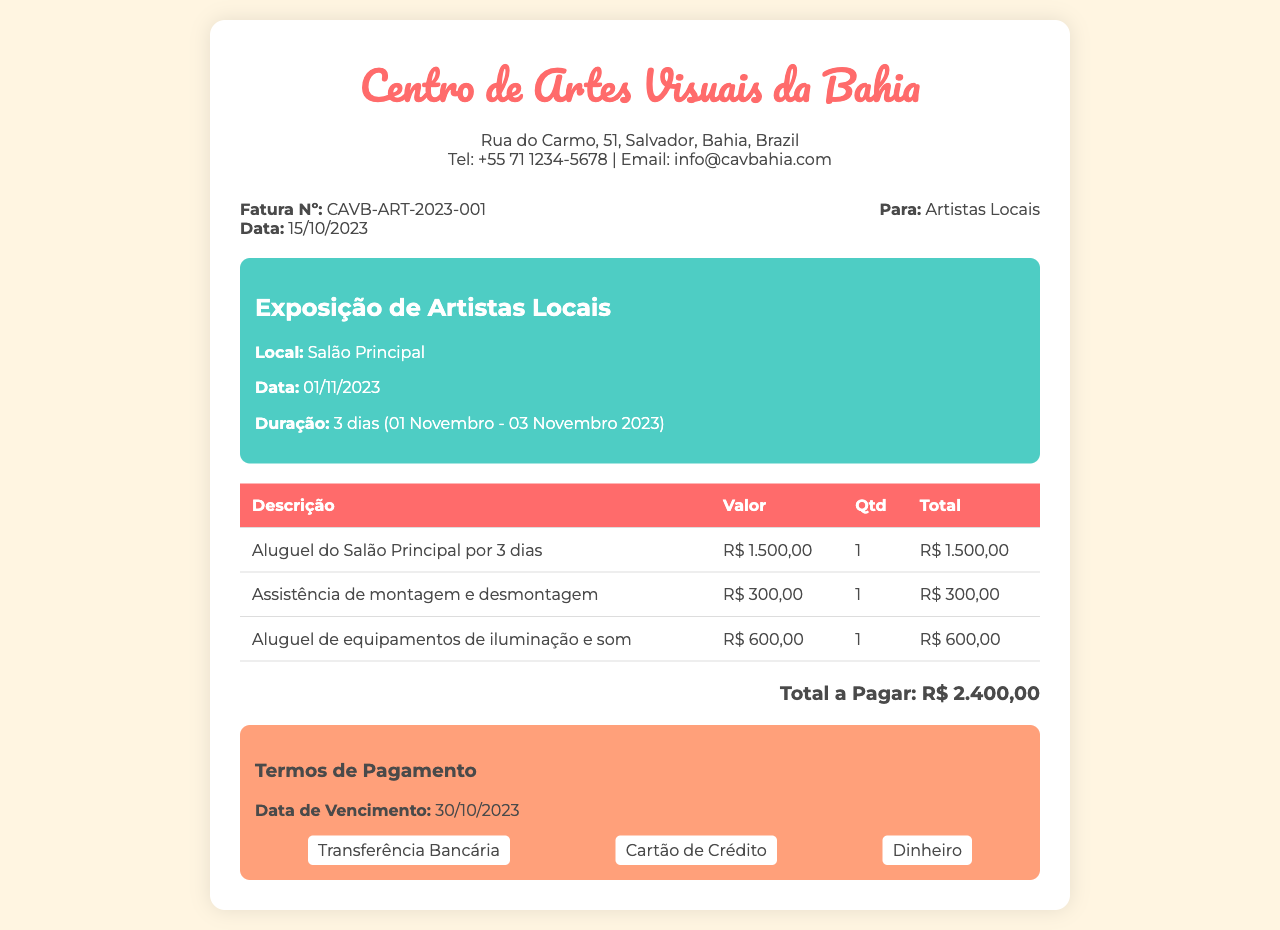Qual é o número da fatura? O número da fatura está listado na seção de detalhes da fatura.
Answer: CAVB-ART-2023-001 Qual é a data de emissão da fatura? A data de emissão da fatura é mencionada logo acima do número da fatura.
Answer: 15/10/2023 Qual é o local da exposição? O local da exposição é indicado na seção de detalhes do evento.
Answer: Salão Principal Quantos dias durará a exposição? A duração da exposição é descrita na parte de detalhes do evento.
Answer: 3 dias Qual é o total a pagar? O total a pagar é mencionado na parte inferior da tabela, destacando o valor total.
Answer: R$ 2.400,00 Qual é a data de vencimento? A data de vencimento é especificada nos termos de pagamento.
Answer: 30/10/2023 Quantia a ser paga pelo aluguel do salão? O valor do aluguel do salão é encontrado na tabela de descrição e valores.
Answer: R$ 1.500,00 Quais métodos de pagamento são aceitos? Os métodos de pagamento são listados na seção de termos de pagamento.
Answer: Transferência Bancária, Cartão de Crédito, Dinheiro Qual é o valor da assistência de montagem e desmontagem? O valor correspondente está incluído na tabela abaixo da descrição dos serviços.
Answer: R$ 300,00 